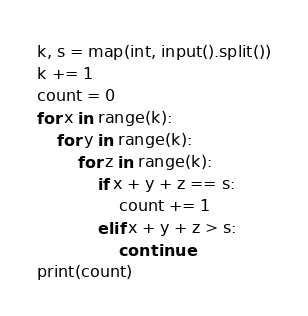Convert code to text. <code><loc_0><loc_0><loc_500><loc_500><_Python_>k, s = map(int, input().split())
k += 1
count = 0
for x in range(k):
    for y in range(k):
        for z in range(k):
            if x + y + z == s:
                count += 1
            elif x + y + z > s:
                continue
print(count)</code> 